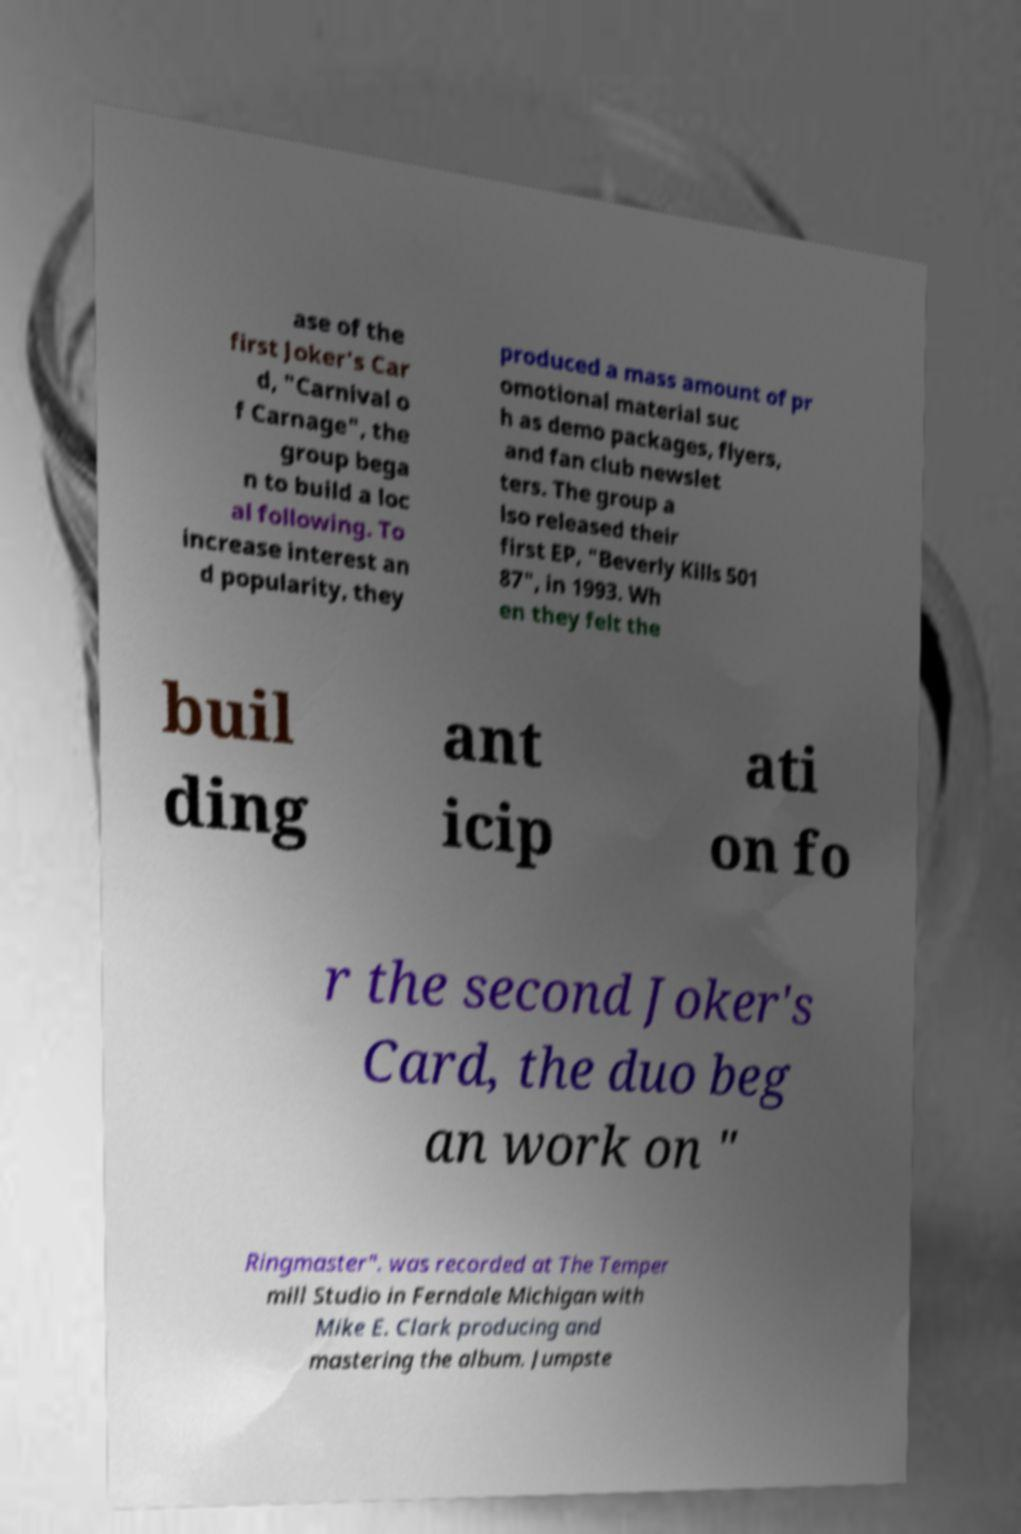I need the written content from this picture converted into text. Can you do that? ase of the first Joker's Car d, "Carnival o f Carnage", the group bega n to build a loc al following. To increase interest an d popularity, they produced a mass amount of pr omotional material suc h as demo packages, flyers, and fan club newslet ters. The group a lso released their first EP, "Beverly Kills 501 87", in 1993. Wh en they felt the buil ding ant icip ati on fo r the second Joker's Card, the duo beg an work on " Ringmaster". was recorded at The Temper mill Studio in Ferndale Michigan with Mike E. Clark producing and mastering the album. Jumpste 